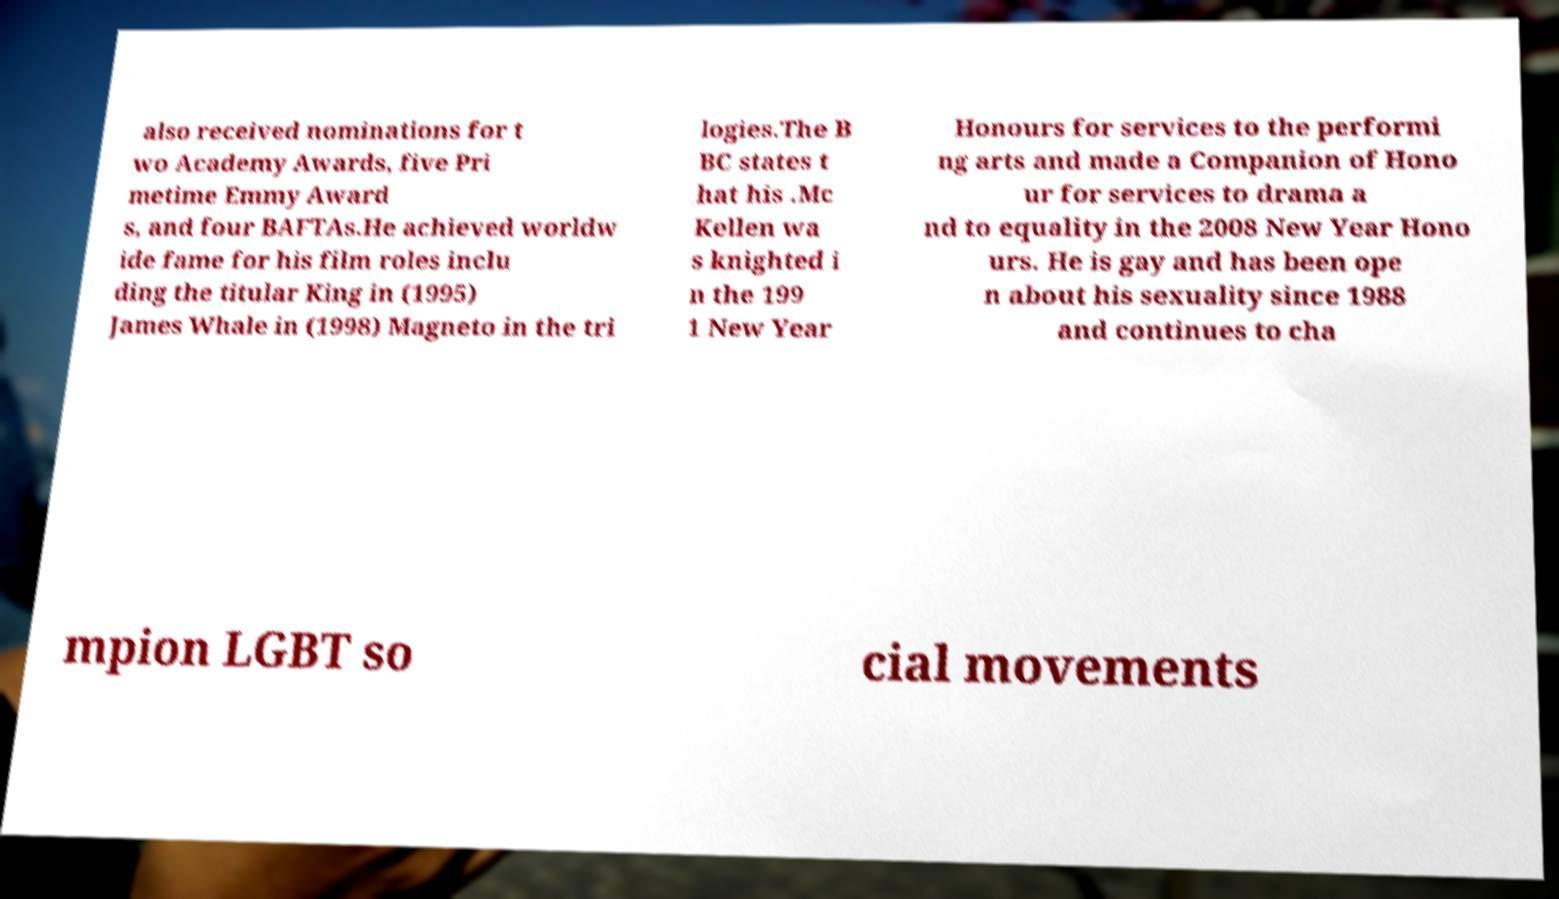There's text embedded in this image that I need extracted. Can you transcribe it verbatim? also received nominations for t wo Academy Awards, five Pri metime Emmy Award s, and four BAFTAs.He achieved worldw ide fame for his film roles inclu ding the titular King in (1995) James Whale in (1998) Magneto in the tri logies.The B BC states t hat his .Mc Kellen wa s knighted i n the 199 1 New Year Honours for services to the performi ng arts and made a Companion of Hono ur for services to drama a nd to equality in the 2008 New Year Hono urs. He is gay and has been ope n about his sexuality since 1988 and continues to cha mpion LGBT so cial movements 